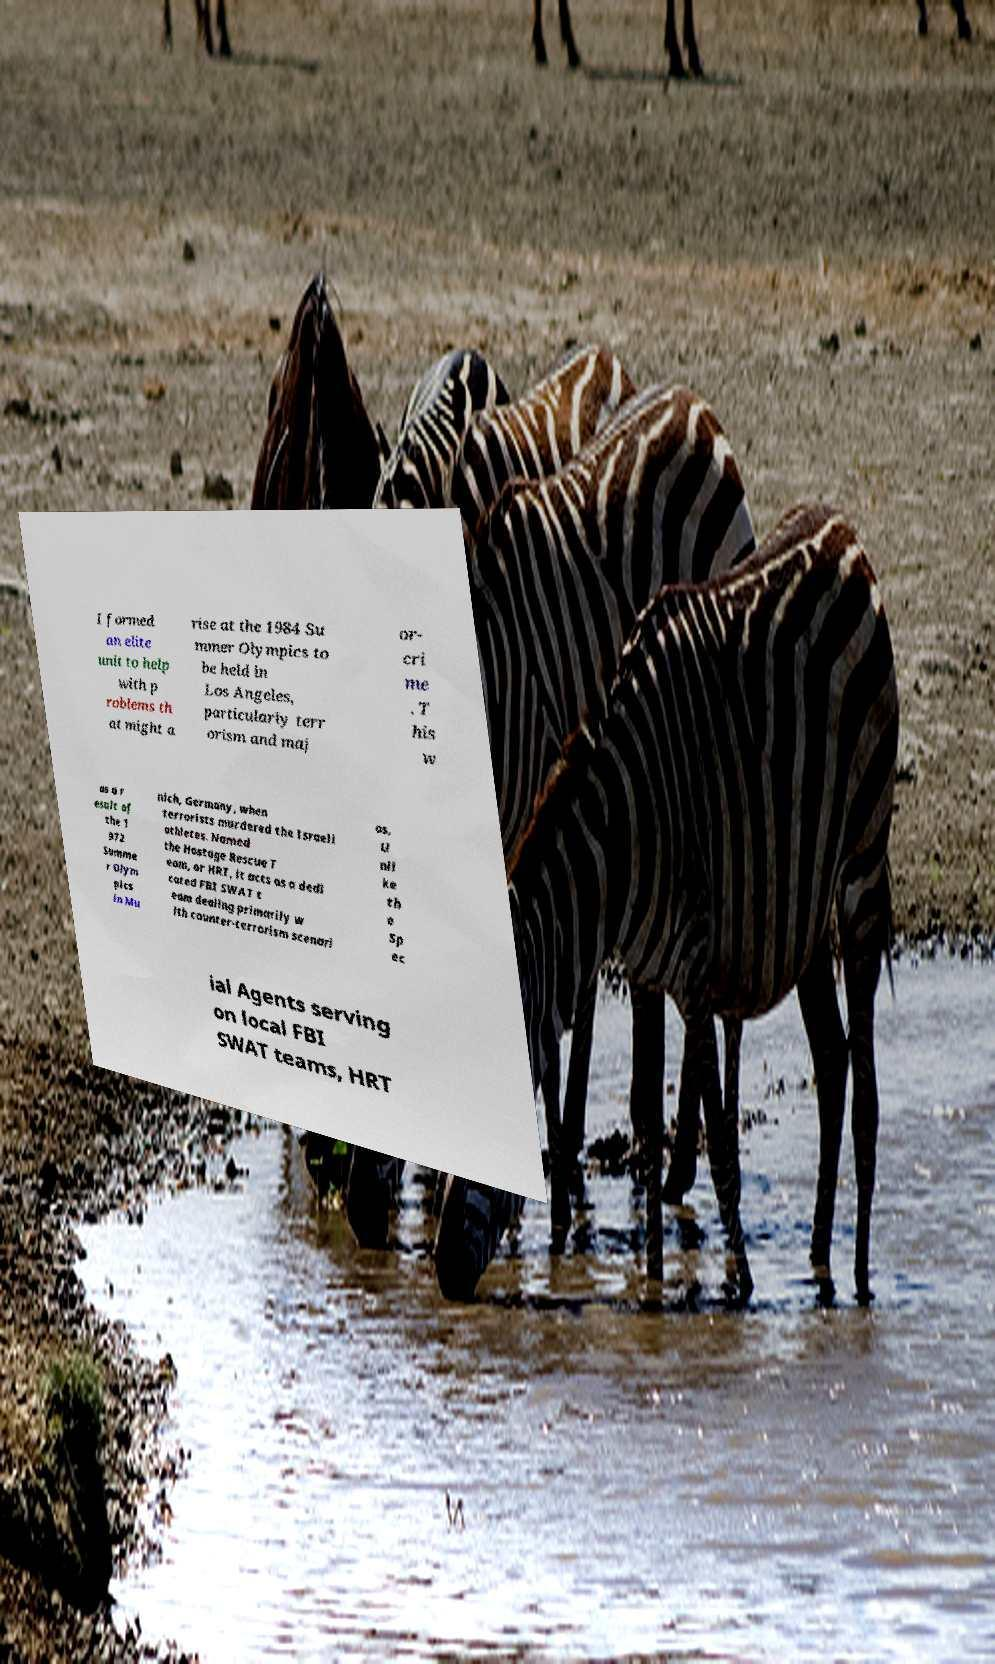Can you read and provide the text displayed in the image?This photo seems to have some interesting text. Can you extract and type it out for me? I formed an elite unit to help with p roblems th at might a rise at the 1984 Su mmer Olympics to be held in Los Angeles, particularly terr orism and maj or- cri me . T his w as a r esult of the 1 972 Summe r Olym pics in Mu nich, Germany, when terrorists murdered the Israeli athletes. Named the Hostage Rescue T eam, or HRT, it acts as a dedi cated FBI SWAT t eam dealing primarily w ith counter-terrorism scenari os. U nli ke th e Sp ec ial Agents serving on local FBI SWAT teams, HRT 